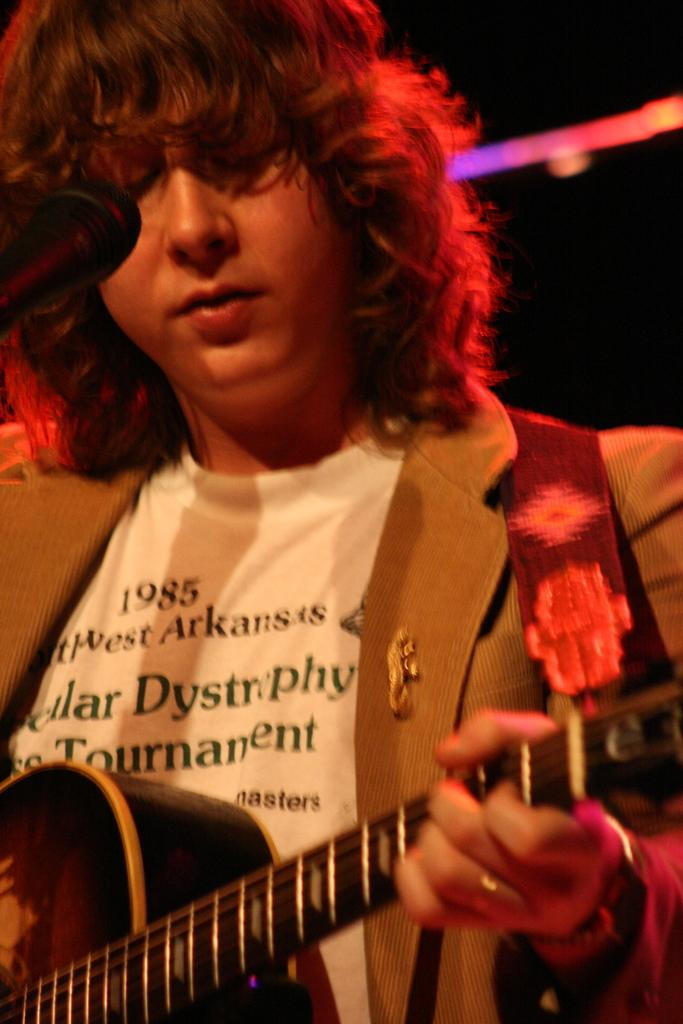What is the main subject in the foreground of the picture? There is a person playing guitar in the foreground of the picture. What object is located on the left side of the picture? There is a microphone on the left side of the picture. What can be seen in the background of the picture? There are lights visible in the background of the picture. How many bikes are parked behind the person playing guitar in the image? There are no bikes visible in the image; it only features a person playing guitar, a microphone, and lights in the background. What type of pickle is being used as a guitar pick in the image? There is no pickle present in the image, and the person playing guitar is not using any unconventional objects as a guitar pick. 